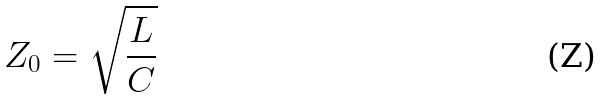Convert formula to latex. <formula><loc_0><loc_0><loc_500><loc_500>Z _ { 0 } = \sqrt { \frac { L } { C } }</formula> 